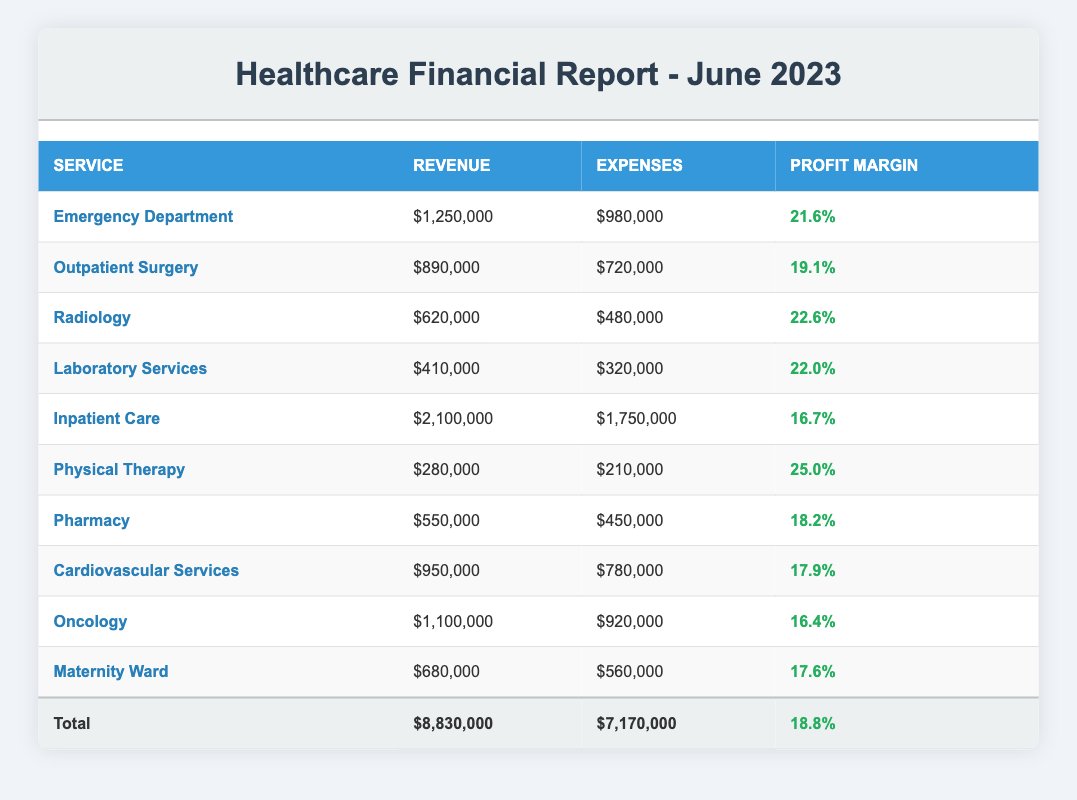What is the revenue for the Emergency Department? The table lists the Emergency Department's revenue in the corresponding cell under the Revenue column, which shows a value of 1,250,000.
Answer: 1,250,000 What is the total profit margin for all healthcare services? The total profit margin for all healthcare services can be found in the last row of the table, labeled as "Total," showing a value of 18.8.
Answer: 18.8 Is the profit margin for Physical Therapy higher than that of Inpatient Care? The profit margin for Physical Therapy is 25.0 while for Inpatient Care it is 16.7. Since 25.0 is greater than 16.7, the answer is yes.
Answer: Yes What is the combined revenue of the Outpatient Surgery and Laboratory Services? To find the combined revenue, we add the revenue of Outpatient Surgery (890,000) and Laboratory Services (410,000). 890,000 + 410,000 equals 1,300,000.
Answer: 1,300,000 Which service has the lowest profit margin? The service with the lowest profit margin can be identified by comparing the profit margins in the Profit Margin column. Inpatient Care has a profit margin of 16.7, which is the lowest.
Answer: Inpatient Care What is the difference between the total expenses and total revenue? The total expenses are listed as 7,170,000 and total revenue is 8,830,000. The difference is calculated by subtracting total expenses from total revenue: 8,830,000 - 7,170,000 equals 1,660,000.
Answer: 1,660,000 Does the Pharmacy make a profit? To determine if the Pharmacy makes a profit, we look at its revenue (550,000) and expenses (450,000). Since revenue is greater than expenses, the answer is yes.
Answer: Yes What is the average revenue across all services? To find the average revenue, we first calculate the total revenue of all services listed (8,830,000) and divide it by the number of services (10). Thus, 8,830,000 divided by 10 equals 883,000.
Answer: 883,000 What percentage of total revenue comes from the Inpatient Care service? The revenue from Inpatient Care is 2,100,000. To find the percentage of total revenue (8,830,000), we calculate (2,100,000 / 8,830,000) and multiply by 100, which results in approximately 23.7%.
Answer: 23.7% 